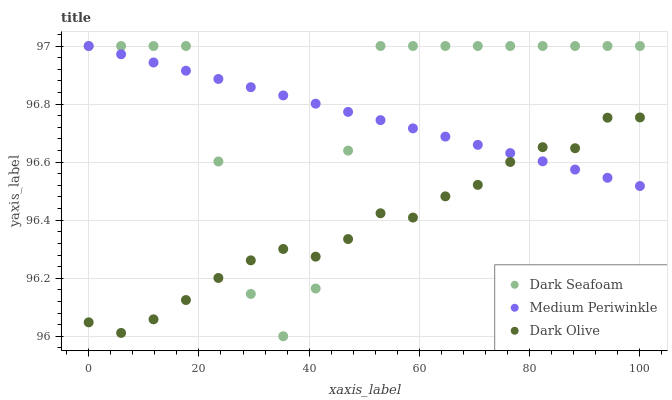Does Dark Olive have the minimum area under the curve?
Answer yes or no. Yes. Does Dark Seafoam have the maximum area under the curve?
Answer yes or no. Yes. Does Medium Periwinkle have the minimum area under the curve?
Answer yes or no. No. Does Medium Periwinkle have the maximum area under the curve?
Answer yes or no. No. Is Medium Periwinkle the smoothest?
Answer yes or no. Yes. Is Dark Seafoam the roughest?
Answer yes or no. Yes. Is Dark Olive the smoothest?
Answer yes or no. No. Is Dark Olive the roughest?
Answer yes or no. No. Does Dark Seafoam have the lowest value?
Answer yes or no. Yes. Does Dark Olive have the lowest value?
Answer yes or no. No. Does Medium Periwinkle have the highest value?
Answer yes or no. Yes. Does Dark Olive have the highest value?
Answer yes or no. No. Does Medium Periwinkle intersect Dark Olive?
Answer yes or no. Yes. Is Medium Periwinkle less than Dark Olive?
Answer yes or no. No. Is Medium Periwinkle greater than Dark Olive?
Answer yes or no. No. 